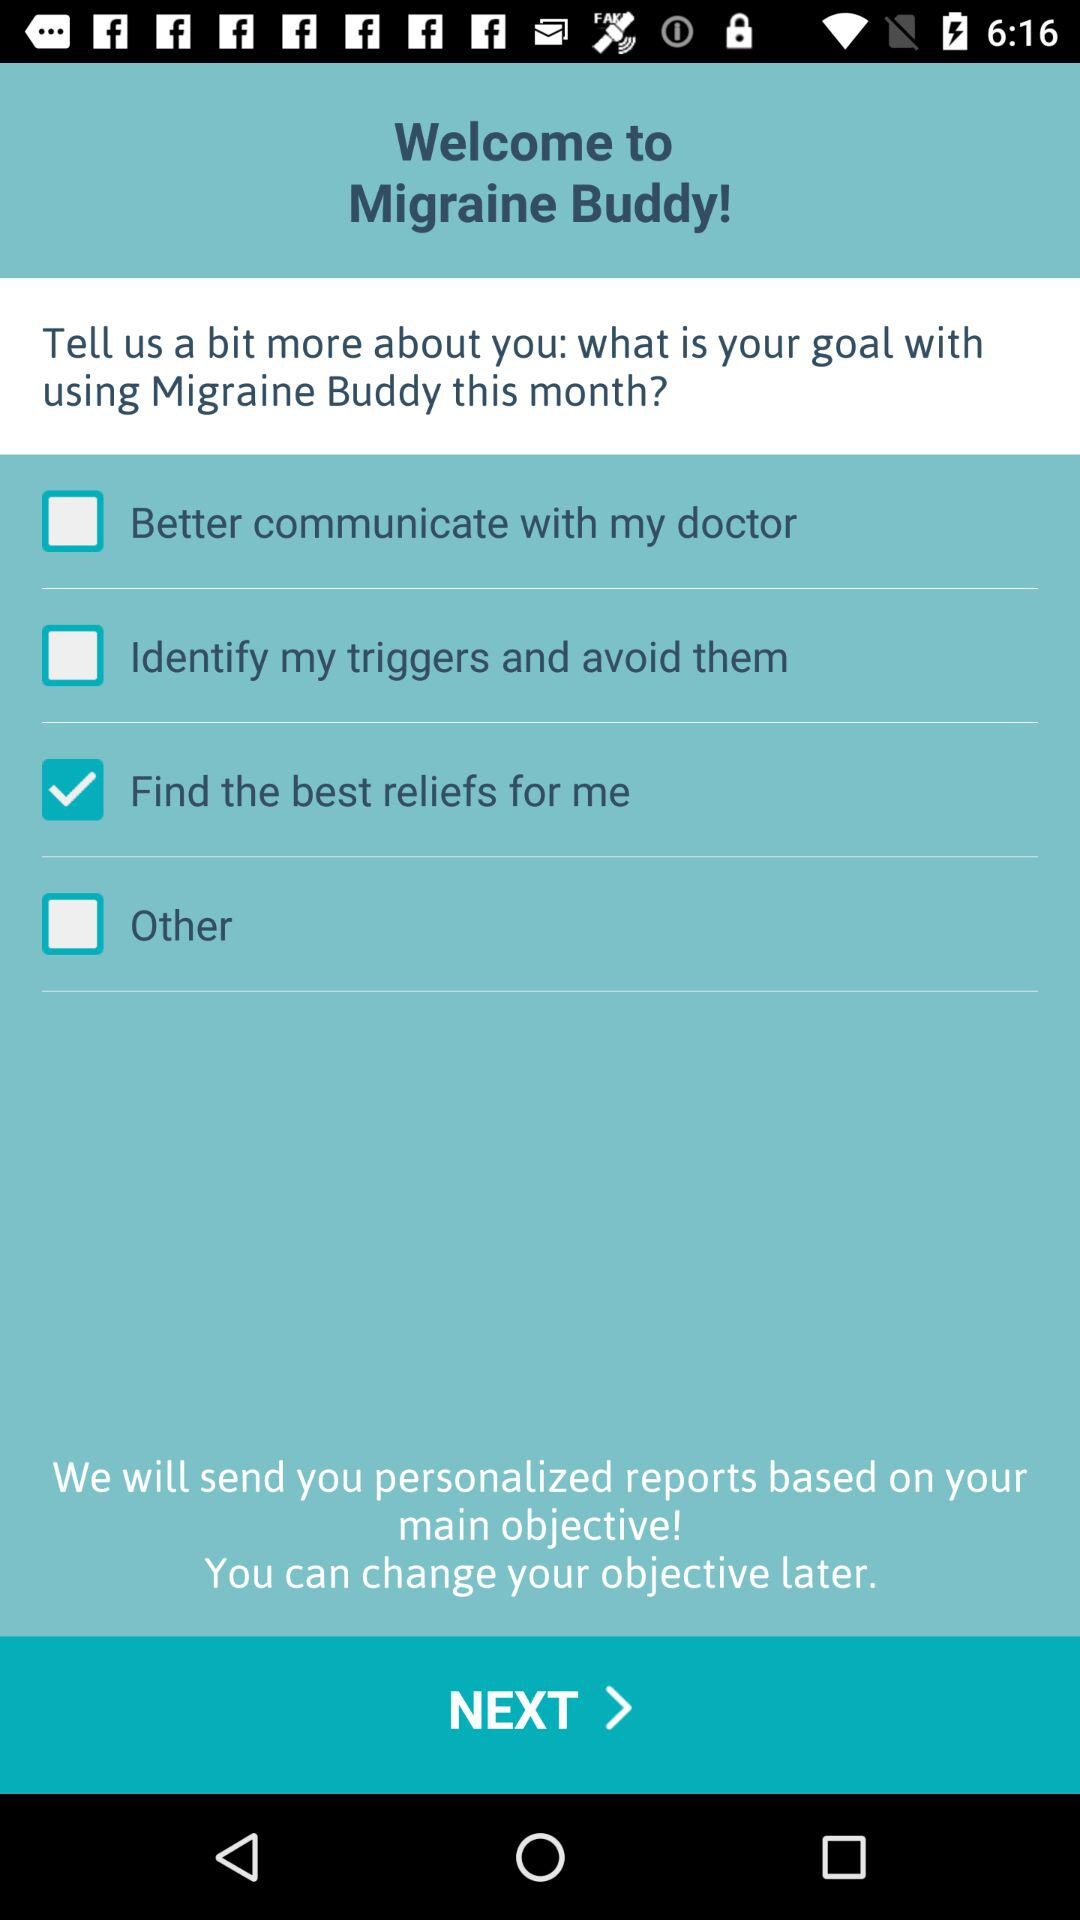Which are the different options? The different options are "Better communicate with my doctor", "Identify my triggers and avoid them", "Find the best reliefs for me" and "Other". 